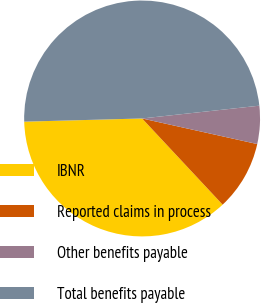Convert chart. <chart><loc_0><loc_0><loc_500><loc_500><pie_chart><fcel>IBNR<fcel>Reported claims in process<fcel>Other benefits payable<fcel>Total benefits payable<nl><fcel>36.53%<fcel>9.56%<fcel>5.21%<fcel>48.7%<nl></chart> 